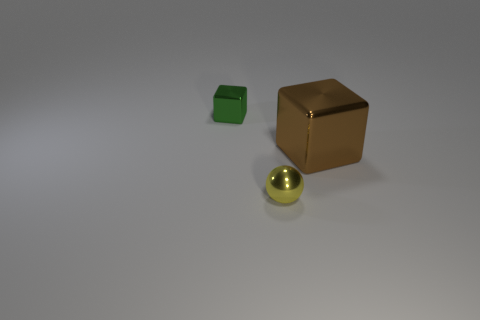How many cubes are green metal objects or brown shiny objects? In the image, there is one cube that is green and appears to be made of metal, as well as one brown cube that has a shiny surface. Therefore, the total number of cubes that are either green metal objects or brown shiny objects is two. 